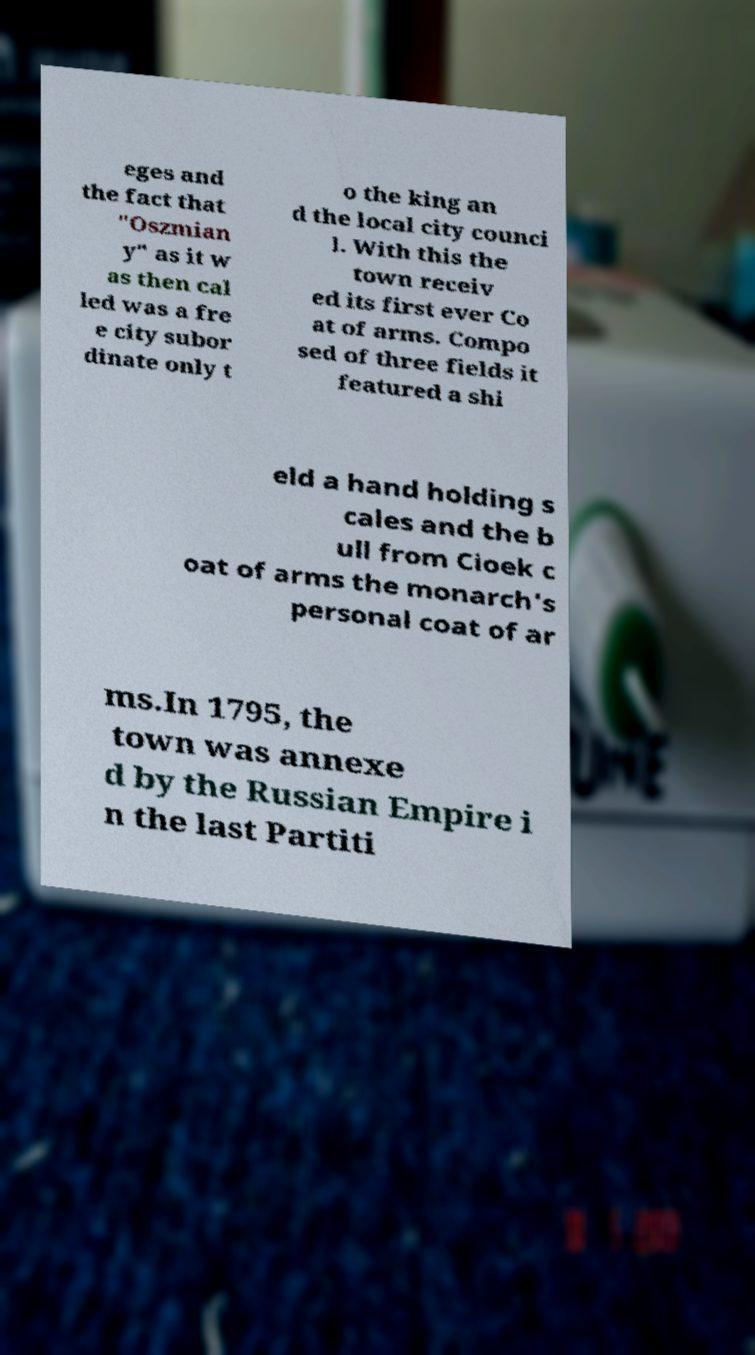I need the written content from this picture converted into text. Can you do that? eges and the fact that "Oszmian y" as it w as then cal led was a fre e city subor dinate only t o the king an d the local city counci l. With this the town receiv ed its first ever Co at of arms. Compo sed of three fields it featured a shi eld a hand holding s cales and the b ull from Cioek c oat of arms the monarch's personal coat of ar ms.In 1795, the town was annexe d by the Russian Empire i n the last Partiti 